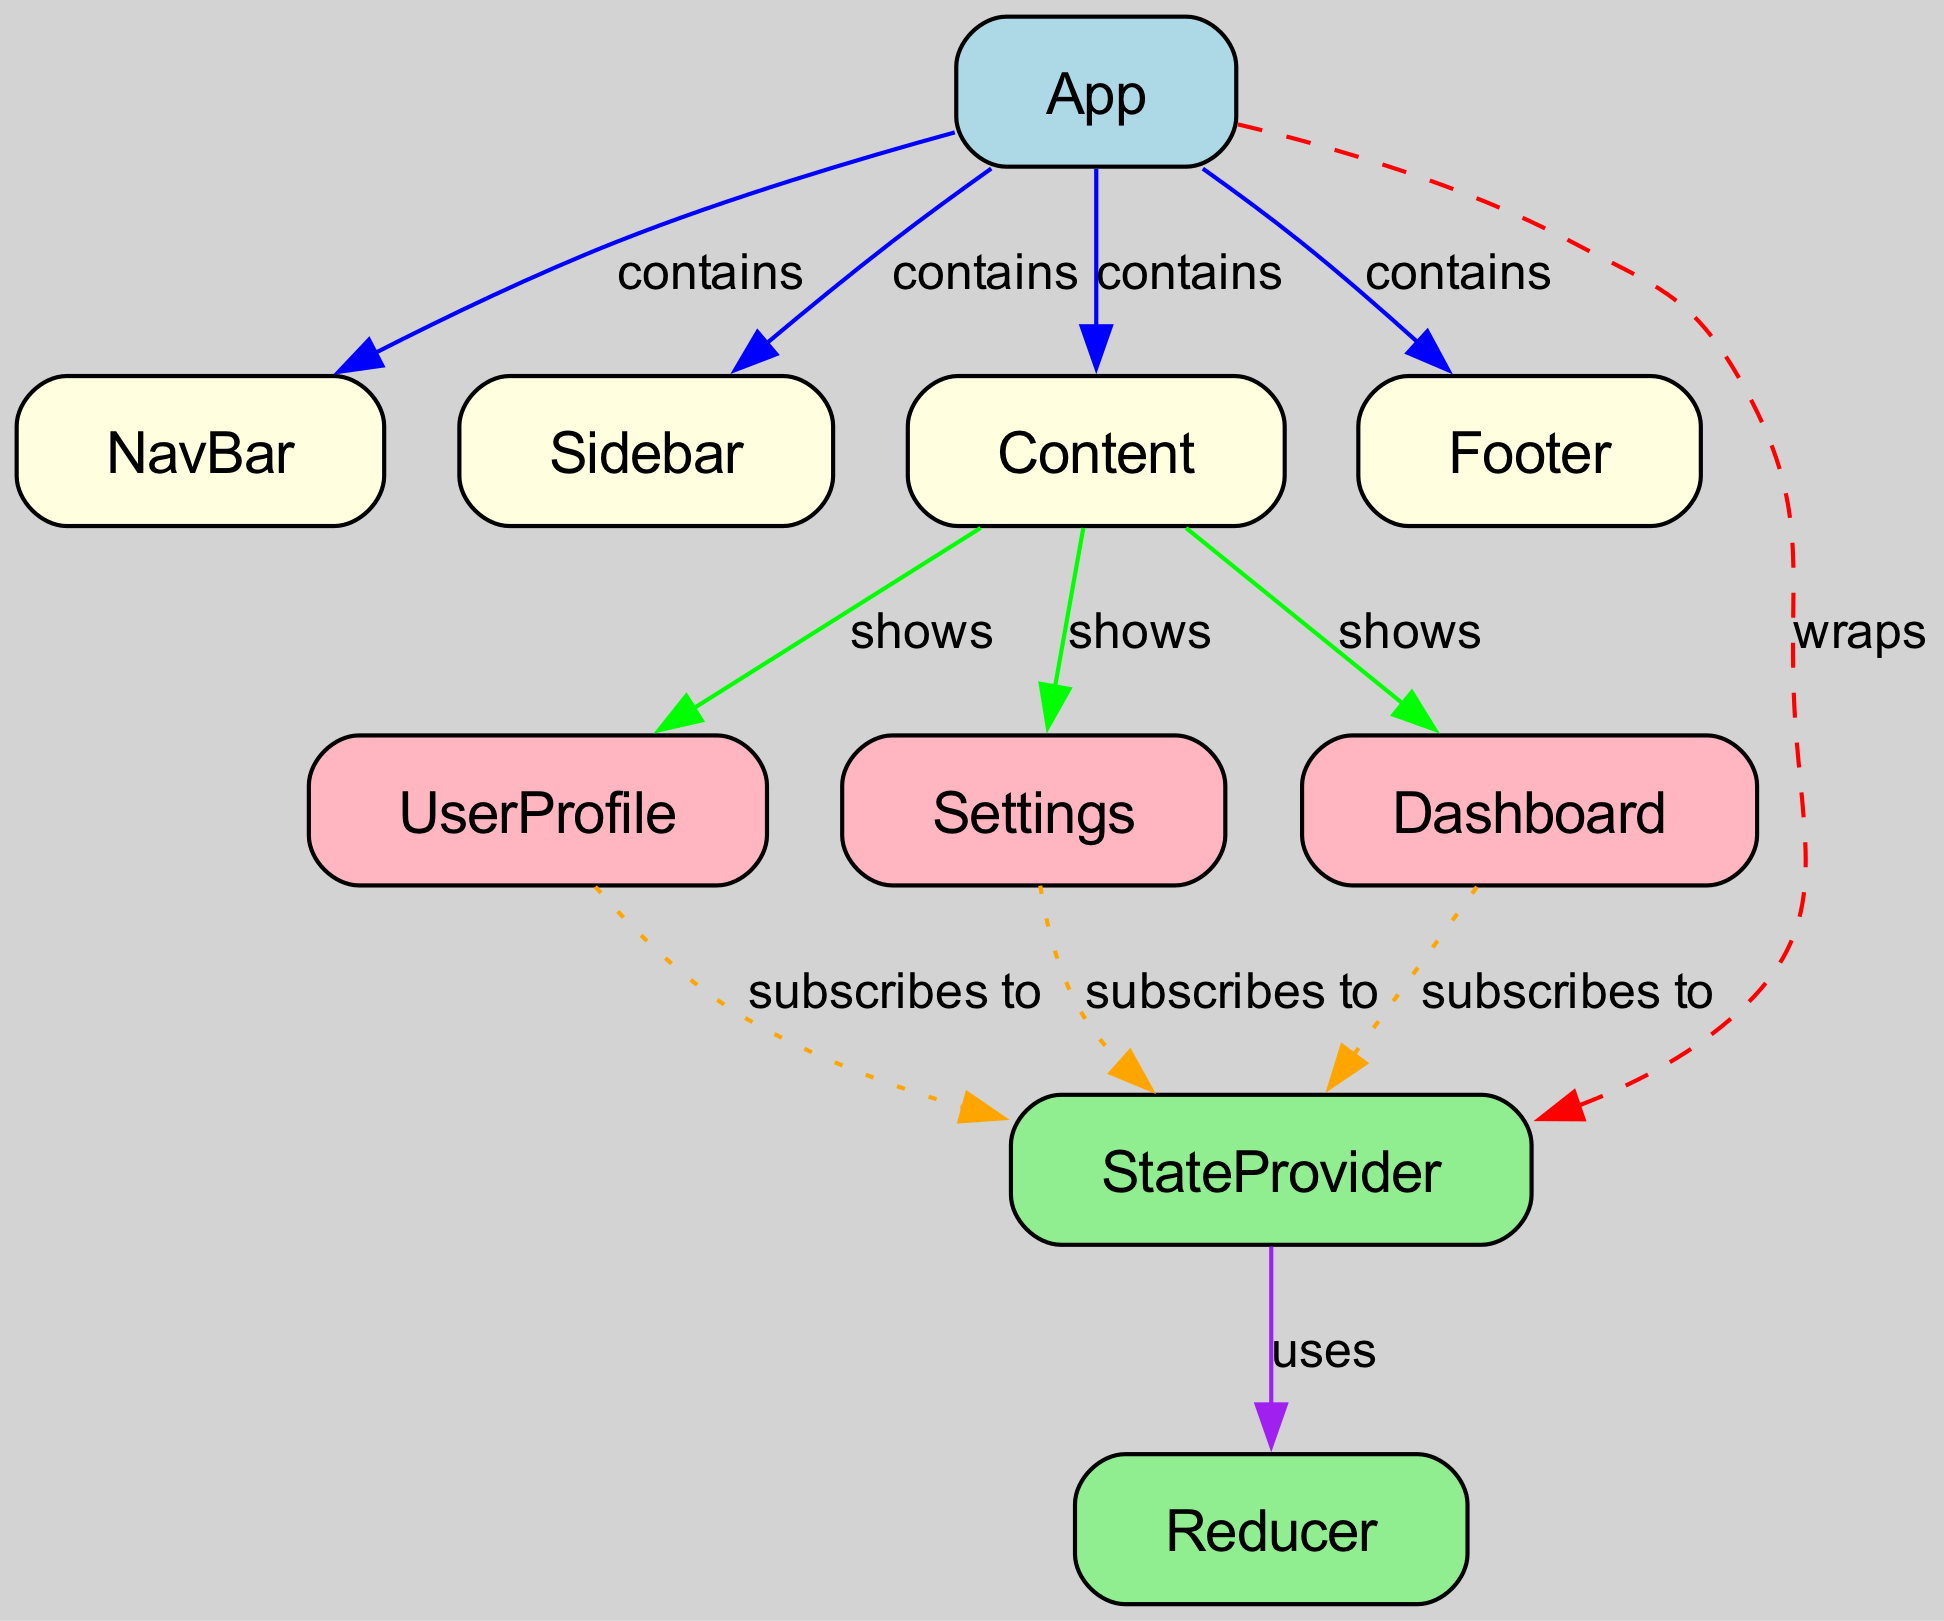What is the top-level component in the hierarchy? The top-level component is the node labeled "App". It is identified as the parent node that contains other components like NavBar, Sidebar, Content, and Footer.
Answer: App How many nodes are present in the diagram? The diagram contains 10 distinct nodes, as indicated in the node list provided. Each node represents a different component in the React application hierarchy.
Answer: 10 What label does the "Content" node show? The "Content" node shows three child components: UserProfile, Settings, and Dashboard. This relationship is indicated by the edges labeled "shows".
Answer: UserProfile, Settings, Dashboard What component wraps the "StateProvider"? The "StateProvider" is wrapped by the "App" node, which is indicated by the edge labeled "wraps" connecting App to StateProvider.
Answer: App Which components subscribe to the "StateProvider"? The components that subscribe to the "StateProvider" are the "Dashboard", "UserProfile", and "Settings" as shown by the edges labeled "subscribes to".
Answer: Dashboard, UserProfile, Settings What is the relationship between "App" and "Footer"? The "App" node contains the "Footer" component, as indicated by the edge labeled "contains". This shows that Footer is a child component of App.
Answer: contains How many components show relationships with "StateProvider"? The "StateProvider" has three components that show relationships with it through the "subscribes to" edges: Dashboard, UserProfile, and Settings.
Answer: 3 Which color is used to represent the "StateProvider" node in the diagram? The "StateProvider" node is represented with the color light green in the diagram. This color visually distinguishes it from other types of nodes.
Answer: light green What type of relationship is indicated by the edge connecting "StateProvider" and "Reducer"? The relationship indicated by the edge connecting "StateProvider" and "Reducer" is labeled "uses". This shows that StateProvider utilizes the Reducer for state management.
Answer: uses 